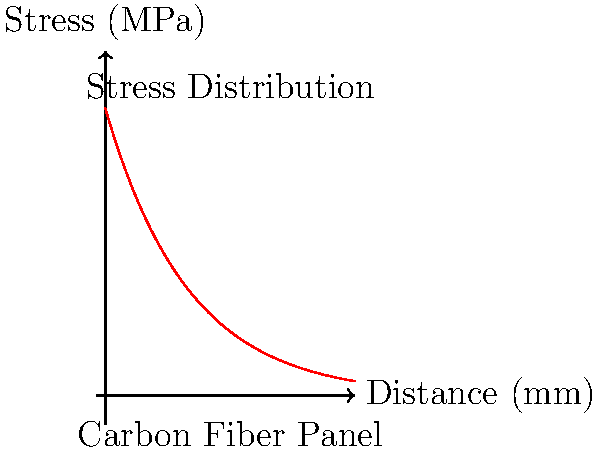The graph above shows the stress distribution in a carbon fiber panel used in our latest EV model. If the maximum allowable stress for this material is 80 MPa, what is the approximate thickness of the panel's edge reinforcement zone needed to ensure structural integrity? To determine the thickness of the edge reinforcement zone, we need to follow these steps:

1. Identify the maximum allowable stress: 80 MPa

2. Analyze the stress distribution curve:
   - The curve shows stress (in MPa) decreasing as we move away from the edge (at x = 0).
   - The stress at the edge (x = 0) is approximately 100 MPa.

3. Find the point where stress drops to the allowable level:
   - We need to find the x-value where the curve intersects the 80 MPa line.
   - This can be approximated from the graph or calculated using the equation:
     $$80 = 100 * e^{-x/10}$$

4. Solve for x:
   $$\ln(0.8) = -x/10$$
   $$x = -10 * \ln(0.8) \approx 2.23 \text{ mm}$$

5. Interpret the result:
   - The stress drops to the allowable level at approximately 2.23 mm from the edge.
   - This represents the minimum thickness of the edge reinforcement zone needed to ensure the stress remains below the maximum allowable stress throughout the panel.

6. Round up for safety and manufacturability:
   - In practice, we would round this up to the nearest standard thickness, likely 2.5 mm or 3 mm.
Answer: 2.5 mm 